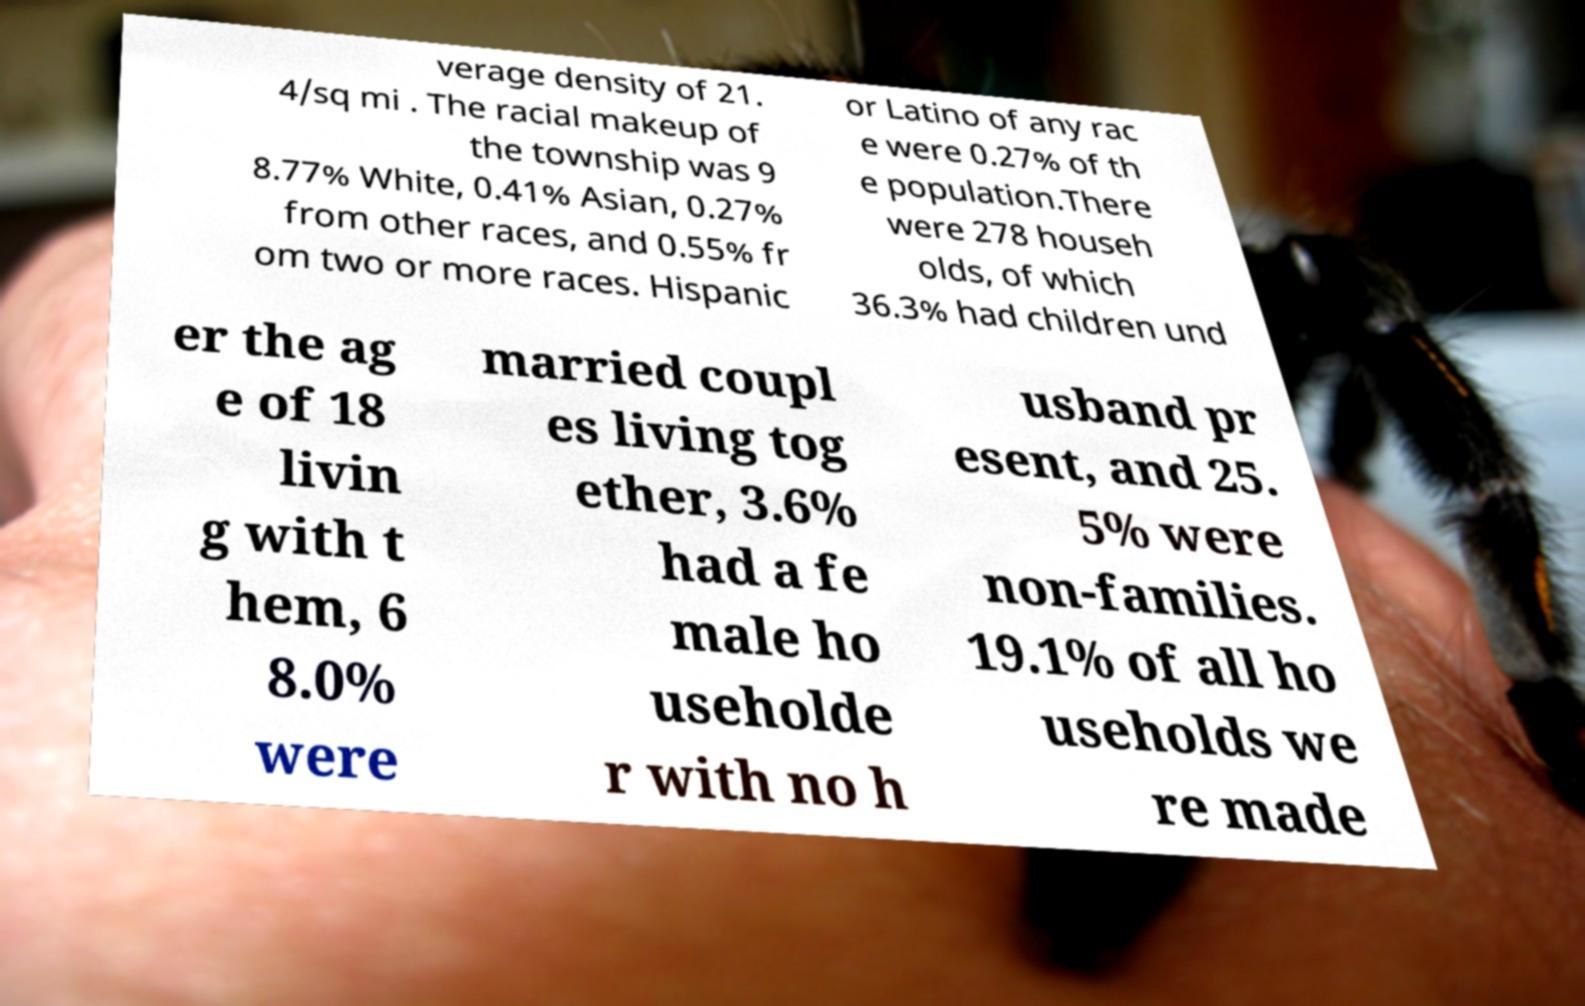Can you read and provide the text displayed in the image?This photo seems to have some interesting text. Can you extract and type it out for me? verage density of 21. 4/sq mi . The racial makeup of the township was 9 8.77% White, 0.41% Asian, 0.27% from other races, and 0.55% fr om two or more races. Hispanic or Latino of any rac e were 0.27% of th e population.There were 278 househ olds, of which 36.3% had children und er the ag e of 18 livin g with t hem, 6 8.0% were married coupl es living tog ether, 3.6% had a fe male ho useholde r with no h usband pr esent, and 25. 5% were non-families. 19.1% of all ho useholds we re made 